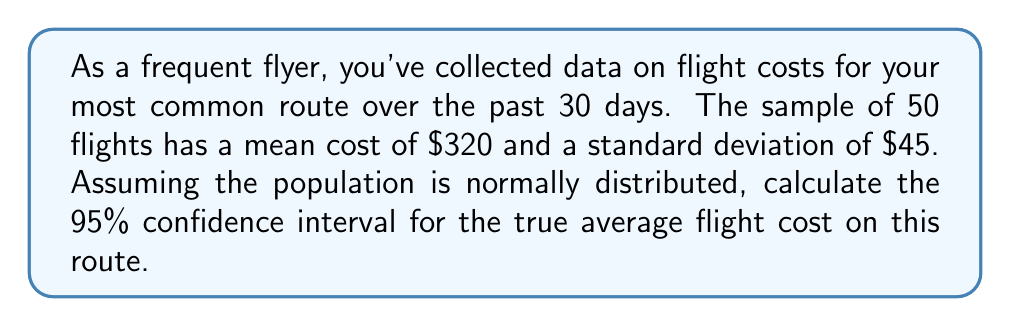Provide a solution to this math problem. To calculate the confidence interval, we'll use the formula:

$$ \text{CI} = \bar{x} \pm t_{\alpha/2} \cdot \frac{s}{\sqrt{n}} $$

Where:
$\bar{x}$ = sample mean = $320
$s$ = sample standard deviation = $45
$n$ = sample size = 50
$t_{\alpha/2}$ = t-value for 95% confidence level with 49 degrees of freedom

Step 1: Determine the t-value
For a 95% confidence level and 49 degrees of freedom, $t_{\alpha/2} = 2.010$ (from t-distribution table)

Step 2: Calculate the margin of error
$$ \text{Margin of Error} = t_{\alpha/2} \cdot \frac{s}{\sqrt{n}} = 2.010 \cdot \frac{45}{\sqrt{50}} \approx 12.78 $$

Step 3: Calculate the confidence interval
Lower bound: $320 - 12.78 = 307.22$
Upper bound: $320 + 12.78 = 332.78$

Therefore, the 95% confidence interval is ($307.22, $332.78).
Answer: ($307.22, $332.78) 